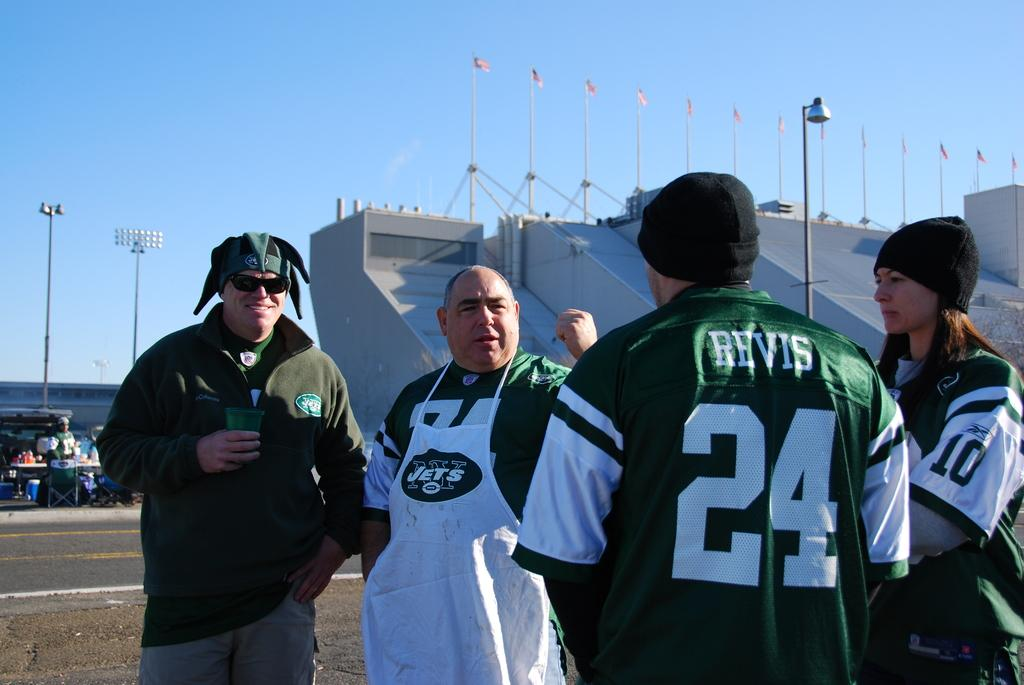<image>
Write a terse but informative summary of the picture. A Jets fan wearing a number 24 Revis jersey chats with other fans during a football tailgate. 